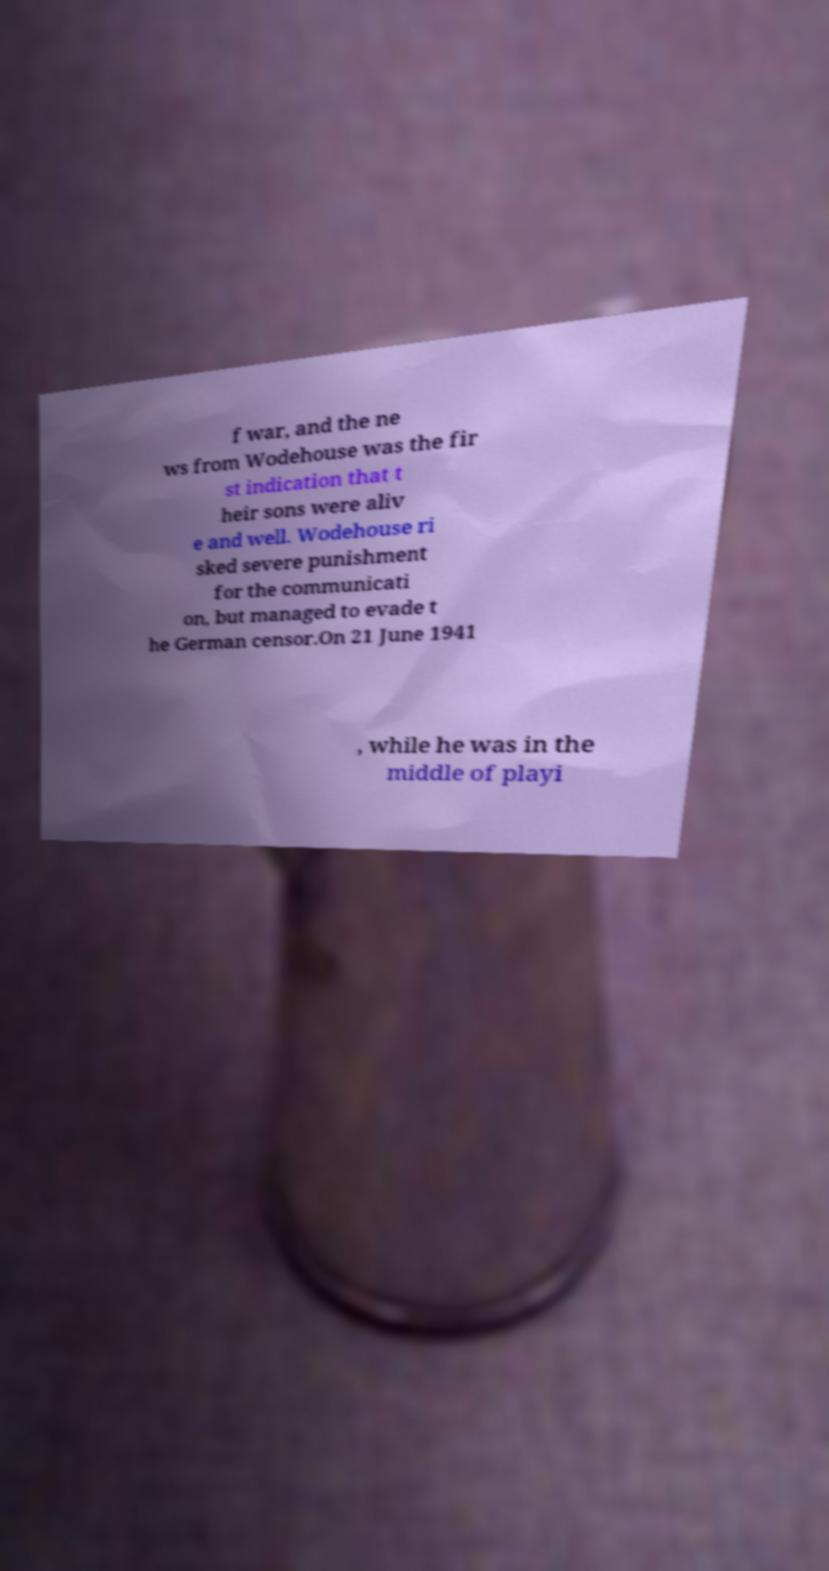Could you assist in decoding the text presented in this image and type it out clearly? f war, and the ne ws from Wodehouse was the fir st indication that t heir sons were aliv e and well. Wodehouse ri sked severe punishment for the communicati on, but managed to evade t he German censor.On 21 June 1941 , while he was in the middle of playi 